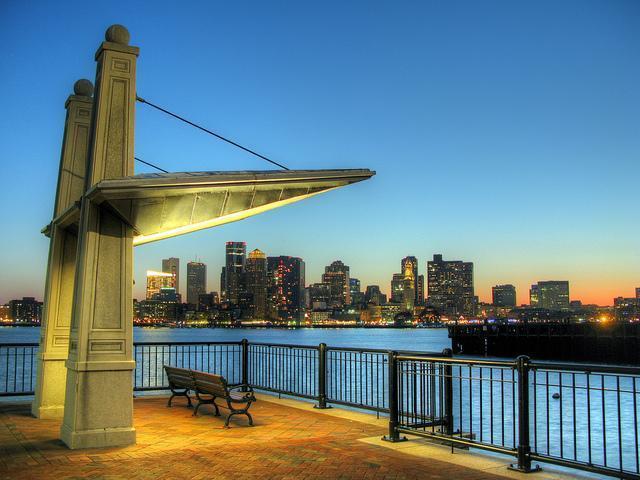How many corners does the railing have?
Give a very brief answer. 3. How many benches are there?
Give a very brief answer. 1. 